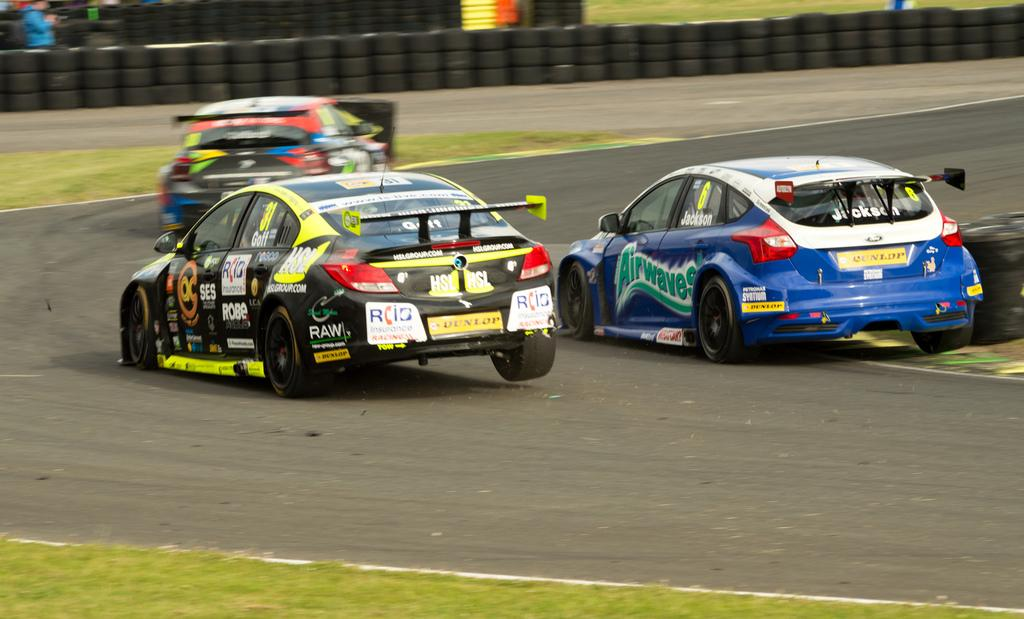What type of vehicles can be seen on the road in the image? There are cars on the road in the image. Can you describe the person's position in relation to the tires? There is a person behind the tires in the image. What objects are visible in the image that are related to the cars? There are tires visible in the image. What type of terrain is at the bottom of the image? There is grass at the bottom of the image. What is the main feature of the image? The main feature of the image is the road. What type of reward is the person holding in the image? There is no reward visible in the image; it only shows cars on the road, a person behind the tires, tires, grass, and a road. 